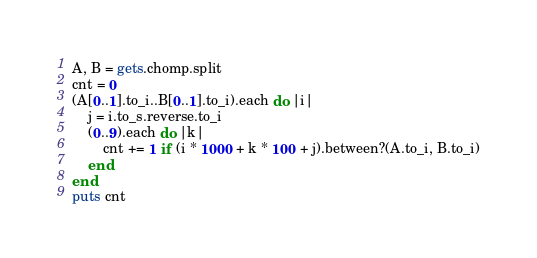<code> <loc_0><loc_0><loc_500><loc_500><_Ruby_>A, B = gets.chomp.split
cnt = 0
(A[0..1].to_i..B[0..1].to_i).each do |i|
    j = i.to_s.reverse.to_i
    (0..9).each do |k|
        cnt += 1 if (i * 1000 + k * 100 + j).between?(A.to_i, B.to_i)
    end
end
puts cnt</code> 